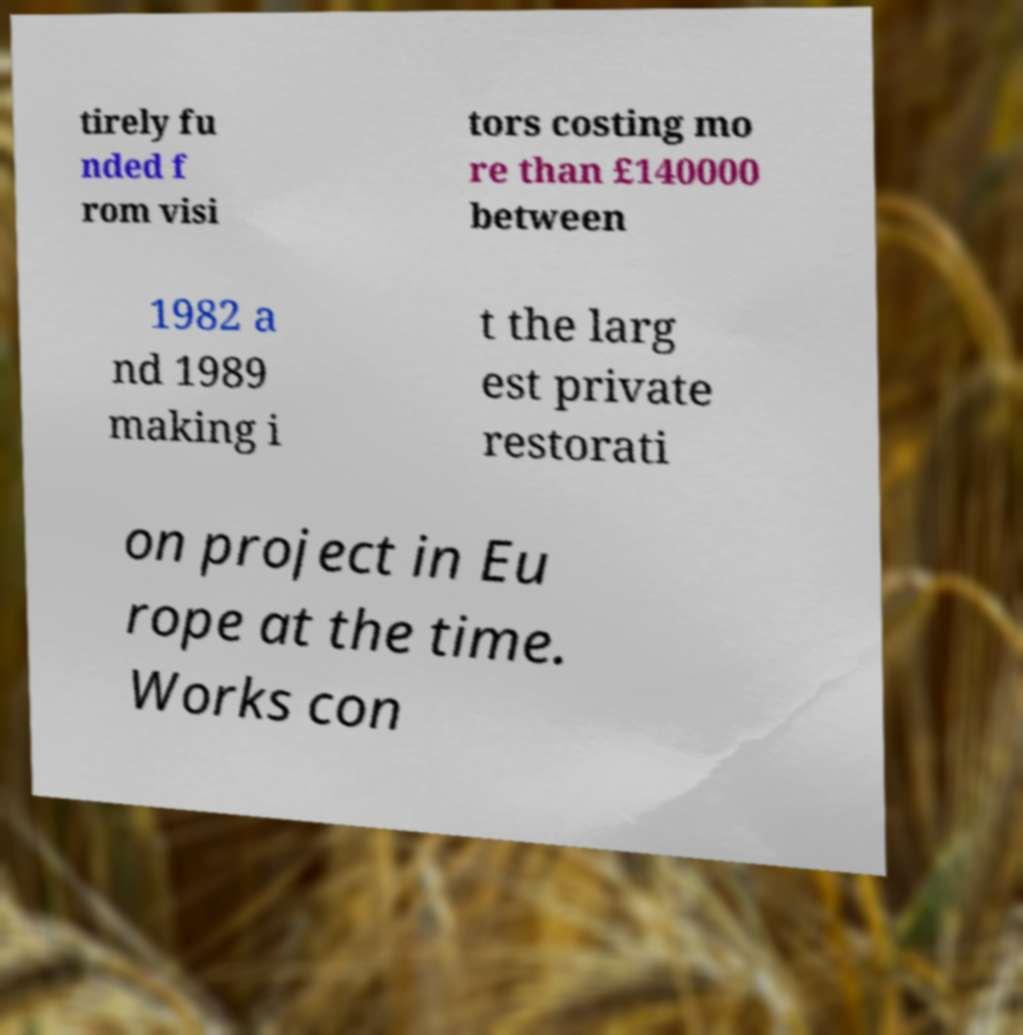What messages or text are displayed in this image? I need them in a readable, typed format. tirely fu nded f rom visi tors costing mo re than £140000 between 1982 a nd 1989 making i t the larg est private restorati on project in Eu rope at the time. Works con 